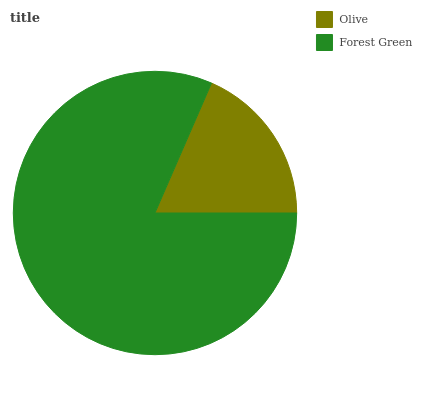Is Olive the minimum?
Answer yes or no. Yes. Is Forest Green the maximum?
Answer yes or no. Yes. Is Forest Green the minimum?
Answer yes or no. No. Is Forest Green greater than Olive?
Answer yes or no. Yes. Is Olive less than Forest Green?
Answer yes or no. Yes. Is Olive greater than Forest Green?
Answer yes or no. No. Is Forest Green less than Olive?
Answer yes or no. No. Is Forest Green the high median?
Answer yes or no. Yes. Is Olive the low median?
Answer yes or no. Yes. Is Olive the high median?
Answer yes or no. No. Is Forest Green the low median?
Answer yes or no. No. 